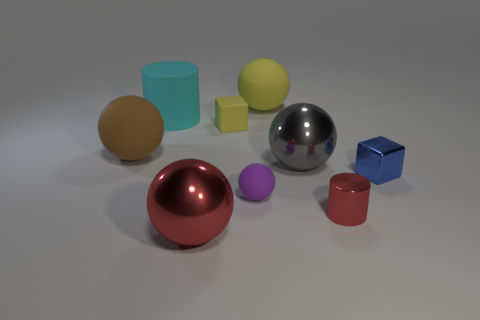Subtract all shiny balls. How many balls are left? 3 Subtract all brown spheres. How many spheres are left? 4 Subtract all spheres. How many objects are left? 4 Add 1 tiny yellow matte objects. How many tiny yellow matte objects are left? 2 Add 9 large brown matte objects. How many large brown matte objects exist? 10 Subtract 0 red cubes. How many objects are left? 9 Subtract 1 cylinders. How many cylinders are left? 1 Subtract all yellow blocks. Subtract all gray spheres. How many blocks are left? 1 Subtract all gray cylinders. How many green blocks are left? 0 Subtract all big purple cubes. Subtract all red things. How many objects are left? 7 